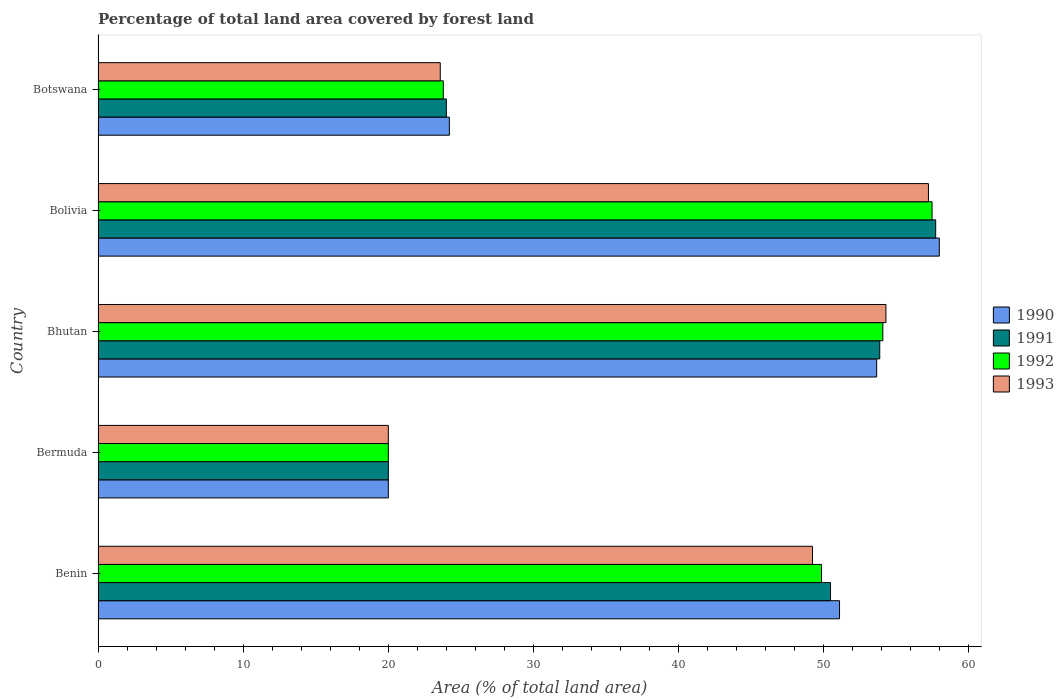How many groups of bars are there?
Make the answer very short. 5. Are the number of bars per tick equal to the number of legend labels?
Provide a succinct answer. Yes. What is the label of the 5th group of bars from the top?
Offer a very short reply. Benin. What is the percentage of forest land in 1991 in Benin?
Ensure brevity in your answer.  50.47. Across all countries, what is the maximum percentage of forest land in 1993?
Offer a very short reply. 57.22. In which country was the percentage of forest land in 1991 maximum?
Make the answer very short. Bolivia. In which country was the percentage of forest land in 1991 minimum?
Keep it short and to the point. Bermuda. What is the total percentage of forest land in 1990 in the graph?
Your response must be concise. 206.91. What is the difference between the percentage of forest land in 1992 in Bermuda and that in Bolivia?
Provide a short and direct response. -37.47. What is the difference between the percentage of forest land in 1990 in Bhutan and the percentage of forest land in 1993 in Benin?
Give a very brief answer. 4.42. What is the average percentage of forest land in 1990 per country?
Your response must be concise. 41.38. What is the difference between the percentage of forest land in 1992 and percentage of forest land in 1990 in Bolivia?
Your response must be concise. -0.5. In how many countries, is the percentage of forest land in 1990 greater than 58 %?
Offer a very short reply. 0. What is the ratio of the percentage of forest land in 1992 in Bhutan to that in Botswana?
Provide a succinct answer. 2.27. Is the percentage of forest land in 1990 in Bhutan less than that in Botswana?
Offer a very short reply. No. What is the difference between the highest and the second highest percentage of forest land in 1990?
Offer a terse response. 4.32. What is the difference between the highest and the lowest percentage of forest land in 1991?
Give a very brief answer. 37.72. In how many countries, is the percentage of forest land in 1993 greater than the average percentage of forest land in 1993 taken over all countries?
Give a very brief answer. 3. Is the sum of the percentage of forest land in 1992 in Bermuda and Botswana greater than the maximum percentage of forest land in 1990 across all countries?
Provide a short and direct response. No. What does the 2nd bar from the top in Benin represents?
Your answer should be very brief. 1992. Is it the case that in every country, the sum of the percentage of forest land in 1991 and percentage of forest land in 1990 is greater than the percentage of forest land in 1993?
Make the answer very short. Yes. Are all the bars in the graph horizontal?
Offer a very short reply. Yes. How many countries are there in the graph?
Offer a terse response. 5. What is the difference between two consecutive major ticks on the X-axis?
Your response must be concise. 10. Are the values on the major ticks of X-axis written in scientific E-notation?
Make the answer very short. No. Does the graph contain any zero values?
Your answer should be compact. No. Where does the legend appear in the graph?
Make the answer very short. Center right. How many legend labels are there?
Offer a terse response. 4. How are the legend labels stacked?
Your response must be concise. Vertical. What is the title of the graph?
Offer a very short reply. Percentage of total land area covered by forest land. Does "2010" appear as one of the legend labels in the graph?
Offer a terse response. No. What is the label or title of the X-axis?
Your response must be concise. Area (% of total land area). What is the Area (% of total land area) of 1990 in Benin?
Offer a very short reply. 51.09. What is the Area (% of total land area) of 1991 in Benin?
Provide a short and direct response. 50.47. What is the Area (% of total land area) in 1992 in Benin?
Offer a terse response. 49.85. What is the Area (% of total land area) in 1993 in Benin?
Your answer should be very brief. 49.23. What is the Area (% of total land area) of 1990 in Bermuda?
Give a very brief answer. 20. What is the Area (% of total land area) in 1991 in Bermuda?
Provide a short and direct response. 20. What is the Area (% of total land area) in 1992 in Bermuda?
Your response must be concise. 20. What is the Area (% of total land area) in 1993 in Bermuda?
Your answer should be compact. 20. What is the Area (% of total land area) in 1990 in Bhutan?
Offer a very short reply. 53.65. What is the Area (% of total land area) of 1991 in Bhutan?
Provide a succinct answer. 53.86. What is the Area (% of total land area) of 1992 in Bhutan?
Give a very brief answer. 54.08. What is the Area (% of total land area) in 1993 in Bhutan?
Provide a succinct answer. 54.29. What is the Area (% of total land area) of 1990 in Bolivia?
Offer a terse response. 57.97. What is the Area (% of total land area) of 1991 in Bolivia?
Ensure brevity in your answer.  57.72. What is the Area (% of total land area) in 1992 in Bolivia?
Provide a short and direct response. 57.47. What is the Area (% of total land area) in 1993 in Bolivia?
Offer a terse response. 57.22. What is the Area (% of total land area) in 1990 in Botswana?
Your response must be concise. 24.21. What is the Area (% of total land area) in 1991 in Botswana?
Make the answer very short. 24. What is the Area (% of total land area) of 1992 in Botswana?
Your response must be concise. 23.79. What is the Area (% of total land area) of 1993 in Botswana?
Provide a short and direct response. 23.58. Across all countries, what is the maximum Area (% of total land area) of 1990?
Your answer should be very brief. 57.97. Across all countries, what is the maximum Area (% of total land area) of 1991?
Keep it short and to the point. 57.72. Across all countries, what is the maximum Area (% of total land area) in 1992?
Your answer should be very brief. 57.47. Across all countries, what is the maximum Area (% of total land area) in 1993?
Provide a short and direct response. 57.22. Across all countries, what is the minimum Area (% of total land area) of 1990?
Provide a short and direct response. 20. Across all countries, what is the minimum Area (% of total land area) in 1992?
Provide a short and direct response. 20. Across all countries, what is the minimum Area (% of total land area) of 1993?
Provide a succinct answer. 20. What is the total Area (% of total land area) of 1990 in the graph?
Ensure brevity in your answer.  206.91. What is the total Area (% of total land area) in 1991 in the graph?
Your answer should be compact. 206.05. What is the total Area (% of total land area) in 1992 in the graph?
Provide a succinct answer. 205.18. What is the total Area (% of total land area) of 1993 in the graph?
Your answer should be compact. 204.31. What is the difference between the Area (% of total land area) in 1990 in Benin and that in Bermuda?
Give a very brief answer. 31.09. What is the difference between the Area (% of total land area) in 1991 in Benin and that in Bermuda?
Your answer should be very brief. 30.47. What is the difference between the Area (% of total land area) in 1992 in Benin and that in Bermuda?
Offer a terse response. 29.85. What is the difference between the Area (% of total land area) of 1993 in Benin and that in Bermuda?
Offer a very short reply. 29.23. What is the difference between the Area (% of total land area) of 1990 in Benin and that in Bhutan?
Keep it short and to the point. -2.56. What is the difference between the Area (% of total land area) of 1991 in Benin and that in Bhutan?
Keep it short and to the point. -3.39. What is the difference between the Area (% of total land area) in 1992 in Benin and that in Bhutan?
Your answer should be very brief. -4.23. What is the difference between the Area (% of total land area) in 1993 in Benin and that in Bhutan?
Keep it short and to the point. -5.06. What is the difference between the Area (% of total land area) in 1990 in Benin and that in Bolivia?
Your response must be concise. -6.88. What is the difference between the Area (% of total land area) in 1991 in Benin and that in Bolivia?
Offer a very short reply. -7.25. What is the difference between the Area (% of total land area) of 1992 in Benin and that in Bolivia?
Keep it short and to the point. -7.62. What is the difference between the Area (% of total land area) in 1993 in Benin and that in Bolivia?
Ensure brevity in your answer.  -7.99. What is the difference between the Area (% of total land area) in 1990 in Benin and that in Botswana?
Provide a succinct answer. 26.89. What is the difference between the Area (% of total land area) of 1991 in Benin and that in Botswana?
Make the answer very short. 26.47. What is the difference between the Area (% of total land area) in 1992 in Benin and that in Botswana?
Provide a succinct answer. 26.06. What is the difference between the Area (% of total land area) in 1993 in Benin and that in Botswana?
Provide a short and direct response. 25.65. What is the difference between the Area (% of total land area) of 1990 in Bermuda and that in Bhutan?
Your answer should be very brief. -33.65. What is the difference between the Area (% of total land area) of 1991 in Bermuda and that in Bhutan?
Provide a succinct answer. -33.86. What is the difference between the Area (% of total land area) in 1992 in Bermuda and that in Bhutan?
Give a very brief answer. -34.08. What is the difference between the Area (% of total land area) of 1993 in Bermuda and that in Bhutan?
Offer a terse response. -34.29. What is the difference between the Area (% of total land area) of 1990 in Bermuda and that in Bolivia?
Offer a terse response. -37.97. What is the difference between the Area (% of total land area) of 1991 in Bermuda and that in Bolivia?
Your response must be concise. -37.72. What is the difference between the Area (% of total land area) in 1992 in Bermuda and that in Bolivia?
Offer a terse response. -37.47. What is the difference between the Area (% of total land area) of 1993 in Bermuda and that in Bolivia?
Provide a succinct answer. -37.22. What is the difference between the Area (% of total land area) of 1990 in Bermuda and that in Botswana?
Your answer should be very brief. -4.21. What is the difference between the Area (% of total land area) in 1991 in Bermuda and that in Botswana?
Your answer should be compact. -4. What is the difference between the Area (% of total land area) in 1992 in Bermuda and that in Botswana?
Provide a short and direct response. -3.79. What is the difference between the Area (% of total land area) of 1993 in Bermuda and that in Botswana?
Offer a very short reply. -3.58. What is the difference between the Area (% of total land area) in 1990 in Bhutan and that in Bolivia?
Offer a terse response. -4.32. What is the difference between the Area (% of total land area) of 1991 in Bhutan and that in Bolivia?
Offer a terse response. -3.85. What is the difference between the Area (% of total land area) of 1992 in Bhutan and that in Bolivia?
Offer a very short reply. -3.39. What is the difference between the Area (% of total land area) of 1993 in Bhutan and that in Bolivia?
Ensure brevity in your answer.  -2.93. What is the difference between the Area (% of total land area) in 1990 in Bhutan and that in Botswana?
Make the answer very short. 29.44. What is the difference between the Area (% of total land area) in 1991 in Bhutan and that in Botswana?
Offer a very short reply. 29.87. What is the difference between the Area (% of total land area) of 1992 in Bhutan and that in Botswana?
Your answer should be compact. 30.29. What is the difference between the Area (% of total land area) of 1993 in Bhutan and that in Botswana?
Offer a very short reply. 30.71. What is the difference between the Area (% of total land area) in 1990 in Bolivia and that in Botswana?
Provide a short and direct response. 33.76. What is the difference between the Area (% of total land area) in 1991 in Bolivia and that in Botswana?
Offer a very short reply. 33.72. What is the difference between the Area (% of total land area) of 1992 in Bolivia and that in Botswana?
Give a very brief answer. 33.68. What is the difference between the Area (% of total land area) of 1993 in Bolivia and that in Botswana?
Your answer should be compact. 33.64. What is the difference between the Area (% of total land area) of 1990 in Benin and the Area (% of total land area) of 1991 in Bermuda?
Offer a terse response. 31.09. What is the difference between the Area (% of total land area) of 1990 in Benin and the Area (% of total land area) of 1992 in Bermuda?
Offer a terse response. 31.09. What is the difference between the Area (% of total land area) in 1990 in Benin and the Area (% of total land area) in 1993 in Bermuda?
Your answer should be very brief. 31.09. What is the difference between the Area (% of total land area) of 1991 in Benin and the Area (% of total land area) of 1992 in Bermuda?
Your answer should be very brief. 30.47. What is the difference between the Area (% of total land area) in 1991 in Benin and the Area (% of total land area) in 1993 in Bermuda?
Your answer should be compact. 30.47. What is the difference between the Area (% of total land area) in 1992 in Benin and the Area (% of total land area) in 1993 in Bermuda?
Your answer should be compact. 29.85. What is the difference between the Area (% of total land area) in 1990 in Benin and the Area (% of total land area) in 1991 in Bhutan?
Keep it short and to the point. -2.77. What is the difference between the Area (% of total land area) of 1990 in Benin and the Area (% of total land area) of 1992 in Bhutan?
Your answer should be very brief. -2.98. What is the difference between the Area (% of total land area) in 1990 in Benin and the Area (% of total land area) in 1993 in Bhutan?
Your answer should be compact. -3.2. What is the difference between the Area (% of total land area) in 1991 in Benin and the Area (% of total land area) in 1992 in Bhutan?
Offer a very short reply. -3.61. What is the difference between the Area (% of total land area) of 1991 in Benin and the Area (% of total land area) of 1993 in Bhutan?
Keep it short and to the point. -3.82. What is the difference between the Area (% of total land area) of 1992 in Benin and the Area (% of total land area) of 1993 in Bhutan?
Keep it short and to the point. -4.44. What is the difference between the Area (% of total land area) in 1990 in Benin and the Area (% of total land area) in 1991 in Bolivia?
Your response must be concise. -6.63. What is the difference between the Area (% of total land area) in 1990 in Benin and the Area (% of total land area) in 1992 in Bolivia?
Make the answer very short. -6.38. What is the difference between the Area (% of total land area) of 1990 in Benin and the Area (% of total land area) of 1993 in Bolivia?
Provide a short and direct response. -6.13. What is the difference between the Area (% of total land area) of 1991 in Benin and the Area (% of total land area) of 1992 in Bolivia?
Give a very brief answer. -7. What is the difference between the Area (% of total land area) of 1991 in Benin and the Area (% of total land area) of 1993 in Bolivia?
Keep it short and to the point. -6.75. What is the difference between the Area (% of total land area) in 1992 in Benin and the Area (% of total land area) in 1993 in Bolivia?
Your response must be concise. -7.37. What is the difference between the Area (% of total land area) in 1990 in Benin and the Area (% of total land area) in 1991 in Botswana?
Your answer should be very brief. 27.09. What is the difference between the Area (% of total land area) in 1990 in Benin and the Area (% of total land area) in 1992 in Botswana?
Offer a terse response. 27.3. What is the difference between the Area (% of total land area) of 1990 in Benin and the Area (% of total land area) of 1993 in Botswana?
Your answer should be very brief. 27.51. What is the difference between the Area (% of total land area) in 1991 in Benin and the Area (% of total land area) in 1992 in Botswana?
Provide a succinct answer. 26.68. What is the difference between the Area (% of total land area) of 1991 in Benin and the Area (% of total land area) of 1993 in Botswana?
Offer a terse response. 26.89. What is the difference between the Area (% of total land area) in 1992 in Benin and the Area (% of total land area) in 1993 in Botswana?
Your response must be concise. 26.27. What is the difference between the Area (% of total land area) of 1990 in Bermuda and the Area (% of total land area) of 1991 in Bhutan?
Ensure brevity in your answer.  -33.86. What is the difference between the Area (% of total land area) of 1990 in Bermuda and the Area (% of total land area) of 1992 in Bhutan?
Keep it short and to the point. -34.08. What is the difference between the Area (% of total land area) of 1990 in Bermuda and the Area (% of total land area) of 1993 in Bhutan?
Make the answer very short. -34.29. What is the difference between the Area (% of total land area) of 1991 in Bermuda and the Area (% of total land area) of 1992 in Bhutan?
Provide a short and direct response. -34.08. What is the difference between the Area (% of total land area) of 1991 in Bermuda and the Area (% of total land area) of 1993 in Bhutan?
Your answer should be compact. -34.29. What is the difference between the Area (% of total land area) in 1992 in Bermuda and the Area (% of total land area) in 1993 in Bhutan?
Give a very brief answer. -34.29. What is the difference between the Area (% of total land area) in 1990 in Bermuda and the Area (% of total land area) in 1991 in Bolivia?
Your answer should be very brief. -37.72. What is the difference between the Area (% of total land area) of 1990 in Bermuda and the Area (% of total land area) of 1992 in Bolivia?
Provide a short and direct response. -37.47. What is the difference between the Area (% of total land area) of 1990 in Bermuda and the Area (% of total land area) of 1993 in Bolivia?
Your answer should be very brief. -37.22. What is the difference between the Area (% of total land area) of 1991 in Bermuda and the Area (% of total land area) of 1992 in Bolivia?
Your answer should be compact. -37.47. What is the difference between the Area (% of total land area) of 1991 in Bermuda and the Area (% of total land area) of 1993 in Bolivia?
Ensure brevity in your answer.  -37.22. What is the difference between the Area (% of total land area) of 1992 in Bermuda and the Area (% of total land area) of 1993 in Bolivia?
Keep it short and to the point. -37.22. What is the difference between the Area (% of total land area) of 1990 in Bermuda and the Area (% of total land area) of 1991 in Botswana?
Give a very brief answer. -4. What is the difference between the Area (% of total land area) of 1990 in Bermuda and the Area (% of total land area) of 1992 in Botswana?
Make the answer very short. -3.79. What is the difference between the Area (% of total land area) of 1990 in Bermuda and the Area (% of total land area) of 1993 in Botswana?
Keep it short and to the point. -3.58. What is the difference between the Area (% of total land area) in 1991 in Bermuda and the Area (% of total land area) in 1992 in Botswana?
Offer a terse response. -3.79. What is the difference between the Area (% of total land area) of 1991 in Bermuda and the Area (% of total land area) of 1993 in Botswana?
Your answer should be compact. -3.58. What is the difference between the Area (% of total land area) in 1992 in Bermuda and the Area (% of total land area) in 1993 in Botswana?
Your answer should be very brief. -3.58. What is the difference between the Area (% of total land area) of 1990 in Bhutan and the Area (% of total land area) of 1991 in Bolivia?
Your response must be concise. -4.07. What is the difference between the Area (% of total land area) in 1990 in Bhutan and the Area (% of total land area) in 1992 in Bolivia?
Ensure brevity in your answer.  -3.82. What is the difference between the Area (% of total land area) in 1990 in Bhutan and the Area (% of total land area) in 1993 in Bolivia?
Your answer should be compact. -3.57. What is the difference between the Area (% of total land area) of 1991 in Bhutan and the Area (% of total land area) of 1992 in Bolivia?
Offer a terse response. -3.6. What is the difference between the Area (% of total land area) in 1991 in Bhutan and the Area (% of total land area) in 1993 in Bolivia?
Provide a succinct answer. -3.35. What is the difference between the Area (% of total land area) in 1992 in Bhutan and the Area (% of total land area) in 1993 in Bolivia?
Your answer should be very brief. -3.14. What is the difference between the Area (% of total land area) of 1990 in Bhutan and the Area (% of total land area) of 1991 in Botswana?
Provide a short and direct response. 29.65. What is the difference between the Area (% of total land area) in 1990 in Bhutan and the Area (% of total land area) in 1992 in Botswana?
Ensure brevity in your answer.  29.86. What is the difference between the Area (% of total land area) of 1990 in Bhutan and the Area (% of total land area) of 1993 in Botswana?
Your answer should be very brief. 30.07. What is the difference between the Area (% of total land area) in 1991 in Bhutan and the Area (% of total land area) in 1992 in Botswana?
Keep it short and to the point. 30.07. What is the difference between the Area (% of total land area) of 1991 in Bhutan and the Area (% of total land area) of 1993 in Botswana?
Keep it short and to the point. 30.28. What is the difference between the Area (% of total land area) of 1992 in Bhutan and the Area (% of total land area) of 1993 in Botswana?
Your answer should be very brief. 30.5. What is the difference between the Area (% of total land area) of 1990 in Bolivia and the Area (% of total land area) of 1991 in Botswana?
Your answer should be compact. 33.97. What is the difference between the Area (% of total land area) in 1990 in Bolivia and the Area (% of total land area) in 1992 in Botswana?
Offer a very short reply. 34.18. What is the difference between the Area (% of total land area) of 1990 in Bolivia and the Area (% of total land area) of 1993 in Botswana?
Offer a terse response. 34.39. What is the difference between the Area (% of total land area) of 1991 in Bolivia and the Area (% of total land area) of 1992 in Botswana?
Provide a short and direct response. 33.93. What is the difference between the Area (% of total land area) in 1991 in Bolivia and the Area (% of total land area) in 1993 in Botswana?
Offer a terse response. 34.14. What is the difference between the Area (% of total land area) in 1992 in Bolivia and the Area (% of total land area) in 1993 in Botswana?
Ensure brevity in your answer.  33.89. What is the average Area (% of total land area) in 1990 per country?
Your answer should be very brief. 41.38. What is the average Area (% of total land area) of 1991 per country?
Ensure brevity in your answer.  41.21. What is the average Area (% of total land area) of 1992 per country?
Provide a short and direct response. 41.04. What is the average Area (% of total land area) of 1993 per country?
Make the answer very short. 40.86. What is the difference between the Area (% of total land area) in 1990 and Area (% of total land area) in 1991 in Benin?
Offer a very short reply. 0.62. What is the difference between the Area (% of total land area) of 1990 and Area (% of total land area) of 1992 in Benin?
Make the answer very short. 1.24. What is the difference between the Area (% of total land area) in 1990 and Area (% of total land area) in 1993 in Benin?
Ensure brevity in your answer.  1.86. What is the difference between the Area (% of total land area) in 1991 and Area (% of total land area) in 1992 in Benin?
Provide a succinct answer. 0.62. What is the difference between the Area (% of total land area) of 1991 and Area (% of total land area) of 1993 in Benin?
Your answer should be compact. 1.24. What is the difference between the Area (% of total land area) of 1992 and Area (% of total land area) of 1993 in Benin?
Provide a short and direct response. 0.62. What is the difference between the Area (% of total land area) in 1990 and Area (% of total land area) in 1991 in Bermuda?
Ensure brevity in your answer.  0. What is the difference between the Area (% of total land area) of 1990 and Area (% of total land area) of 1992 in Bermuda?
Provide a succinct answer. 0. What is the difference between the Area (% of total land area) in 1991 and Area (% of total land area) in 1993 in Bermuda?
Ensure brevity in your answer.  0. What is the difference between the Area (% of total land area) in 1990 and Area (% of total land area) in 1991 in Bhutan?
Your response must be concise. -0.21. What is the difference between the Area (% of total land area) in 1990 and Area (% of total land area) in 1992 in Bhutan?
Your answer should be very brief. -0.43. What is the difference between the Area (% of total land area) of 1990 and Area (% of total land area) of 1993 in Bhutan?
Your response must be concise. -0.64. What is the difference between the Area (% of total land area) in 1991 and Area (% of total land area) in 1992 in Bhutan?
Provide a short and direct response. -0.21. What is the difference between the Area (% of total land area) in 1991 and Area (% of total land area) in 1993 in Bhutan?
Your answer should be compact. -0.43. What is the difference between the Area (% of total land area) of 1992 and Area (% of total land area) of 1993 in Bhutan?
Keep it short and to the point. -0.21. What is the difference between the Area (% of total land area) in 1990 and Area (% of total land area) in 1991 in Bolivia?
Ensure brevity in your answer.  0.25. What is the difference between the Area (% of total land area) in 1990 and Area (% of total land area) in 1992 in Bolivia?
Provide a short and direct response. 0.5. What is the difference between the Area (% of total land area) in 1990 and Area (% of total land area) in 1993 in Bolivia?
Provide a succinct answer. 0.75. What is the difference between the Area (% of total land area) in 1991 and Area (% of total land area) in 1992 in Bolivia?
Your answer should be very brief. 0.25. What is the difference between the Area (% of total land area) of 1991 and Area (% of total land area) of 1993 in Bolivia?
Ensure brevity in your answer.  0.5. What is the difference between the Area (% of total land area) in 1992 and Area (% of total land area) in 1993 in Bolivia?
Give a very brief answer. 0.25. What is the difference between the Area (% of total land area) of 1990 and Area (% of total land area) of 1991 in Botswana?
Ensure brevity in your answer.  0.21. What is the difference between the Area (% of total land area) in 1990 and Area (% of total land area) in 1992 in Botswana?
Provide a succinct answer. 0.42. What is the difference between the Area (% of total land area) in 1990 and Area (% of total land area) in 1993 in Botswana?
Provide a short and direct response. 0.63. What is the difference between the Area (% of total land area) of 1991 and Area (% of total land area) of 1992 in Botswana?
Make the answer very short. 0.21. What is the difference between the Area (% of total land area) in 1991 and Area (% of total land area) in 1993 in Botswana?
Your answer should be very brief. 0.42. What is the difference between the Area (% of total land area) in 1992 and Area (% of total land area) in 1993 in Botswana?
Ensure brevity in your answer.  0.21. What is the ratio of the Area (% of total land area) of 1990 in Benin to that in Bermuda?
Provide a short and direct response. 2.55. What is the ratio of the Area (% of total land area) of 1991 in Benin to that in Bermuda?
Offer a very short reply. 2.52. What is the ratio of the Area (% of total land area) in 1992 in Benin to that in Bermuda?
Offer a very short reply. 2.49. What is the ratio of the Area (% of total land area) in 1993 in Benin to that in Bermuda?
Your response must be concise. 2.46. What is the ratio of the Area (% of total land area) in 1990 in Benin to that in Bhutan?
Provide a short and direct response. 0.95. What is the ratio of the Area (% of total land area) in 1991 in Benin to that in Bhutan?
Provide a short and direct response. 0.94. What is the ratio of the Area (% of total land area) of 1992 in Benin to that in Bhutan?
Offer a very short reply. 0.92. What is the ratio of the Area (% of total land area) of 1993 in Benin to that in Bhutan?
Your answer should be very brief. 0.91. What is the ratio of the Area (% of total land area) of 1990 in Benin to that in Bolivia?
Provide a succinct answer. 0.88. What is the ratio of the Area (% of total land area) of 1991 in Benin to that in Bolivia?
Provide a short and direct response. 0.87. What is the ratio of the Area (% of total land area) of 1992 in Benin to that in Bolivia?
Give a very brief answer. 0.87. What is the ratio of the Area (% of total land area) of 1993 in Benin to that in Bolivia?
Your answer should be very brief. 0.86. What is the ratio of the Area (% of total land area) in 1990 in Benin to that in Botswana?
Provide a short and direct response. 2.11. What is the ratio of the Area (% of total land area) of 1991 in Benin to that in Botswana?
Offer a very short reply. 2.1. What is the ratio of the Area (% of total land area) in 1992 in Benin to that in Botswana?
Keep it short and to the point. 2.1. What is the ratio of the Area (% of total land area) in 1993 in Benin to that in Botswana?
Provide a succinct answer. 2.09. What is the ratio of the Area (% of total land area) in 1990 in Bermuda to that in Bhutan?
Offer a very short reply. 0.37. What is the ratio of the Area (% of total land area) in 1991 in Bermuda to that in Bhutan?
Keep it short and to the point. 0.37. What is the ratio of the Area (% of total land area) in 1992 in Bermuda to that in Bhutan?
Your response must be concise. 0.37. What is the ratio of the Area (% of total land area) of 1993 in Bermuda to that in Bhutan?
Offer a very short reply. 0.37. What is the ratio of the Area (% of total land area) in 1990 in Bermuda to that in Bolivia?
Provide a succinct answer. 0.34. What is the ratio of the Area (% of total land area) in 1991 in Bermuda to that in Bolivia?
Your response must be concise. 0.35. What is the ratio of the Area (% of total land area) of 1992 in Bermuda to that in Bolivia?
Your answer should be compact. 0.35. What is the ratio of the Area (% of total land area) in 1993 in Bermuda to that in Bolivia?
Your response must be concise. 0.35. What is the ratio of the Area (% of total land area) of 1990 in Bermuda to that in Botswana?
Give a very brief answer. 0.83. What is the ratio of the Area (% of total land area) of 1991 in Bermuda to that in Botswana?
Provide a succinct answer. 0.83. What is the ratio of the Area (% of total land area) of 1992 in Bermuda to that in Botswana?
Give a very brief answer. 0.84. What is the ratio of the Area (% of total land area) in 1993 in Bermuda to that in Botswana?
Keep it short and to the point. 0.85. What is the ratio of the Area (% of total land area) of 1990 in Bhutan to that in Bolivia?
Provide a succinct answer. 0.93. What is the ratio of the Area (% of total land area) of 1991 in Bhutan to that in Bolivia?
Keep it short and to the point. 0.93. What is the ratio of the Area (% of total land area) of 1992 in Bhutan to that in Bolivia?
Offer a very short reply. 0.94. What is the ratio of the Area (% of total land area) of 1993 in Bhutan to that in Bolivia?
Give a very brief answer. 0.95. What is the ratio of the Area (% of total land area) in 1990 in Bhutan to that in Botswana?
Give a very brief answer. 2.22. What is the ratio of the Area (% of total land area) of 1991 in Bhutan to that in Botswana?
Ensure brevity in your answer.  2.24. What is the ratio of the Area (% of total land area) of 1992 in Bhutan to that in Botswana?
Your response must be concise. 2.27. What is the ratio of the Area (% of total land area) of 1993 in Bhutan to that in Botswana?
Ensure brevity in your answer.  2.3. What is the ratio of the Area (% of total land area) of 1990 in Bolivia to that in Botswana?
Give a very brief answer. 2.39. What is the ratio of the Area (% of total land area) of 1991 in Bolivia to that in Botswana?
Give a very brief answer. 2.41. What is the ratio of the Area (% of total land area) in 1992 in Bolivia to that in Botswana?
Make the answer very short. 2.42. What is the ratio of the Area (% of total land area) in 1993 in Bolivia to that in Botswana?
Offer a very short reply. 2.43. What is the difference between the highest and the second highest Area (% of total land area) of 1990?
Give a very brief answer. 4.32. What is the difference between the highest and the second highest Area (% of total land area) of 1991?
Make the answer very short. 3.85. What is the difference between the highest and the second highest Area (% of total land area) of 1992?
Keep it short and to the point. 3.39. What is the difference between the highest and the second highest Area (% of total land area) in 1993?
Offer a very short reply. 2.93. What is the difference between the highest and the lowest Area (% of total land area) in 1990?
Ensure brevity in your answer.  37.97. What is the difference between the highest and the lowest Area (% of total land area) in 1991?
Your answer should be very brief. 37.72. What is the difference between the highest and the lowest Area (% of total land area) in 1992?
Offer a very short reply. 37.47. What is the difference between the highest and the lowest Area (% of total land area) of 1993?
Ensure brevity in your answer.  37.22. 